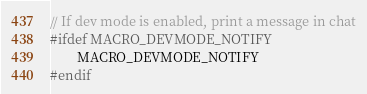<code> <loc_0><loc_0><loc_500><loc_500><_C++_>// If dev mode is enabled, print a message in chat
#ifdef MACRO_DEVMODE_NOTIFY
        MACRO_DEVMODE_NOTIFY
#endif
</code> 